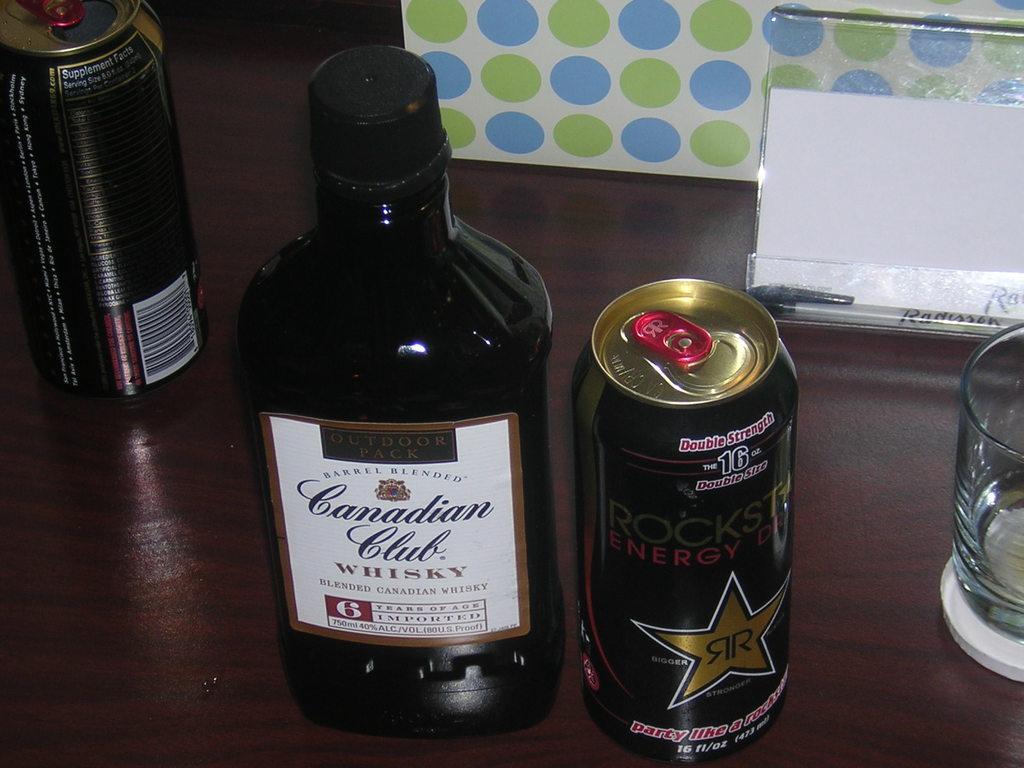What drink is in the can on the right?
Keep it short and to the point. Rockstar. What brand of whisky is being shown?
Offer a terse response. Canadian club. 